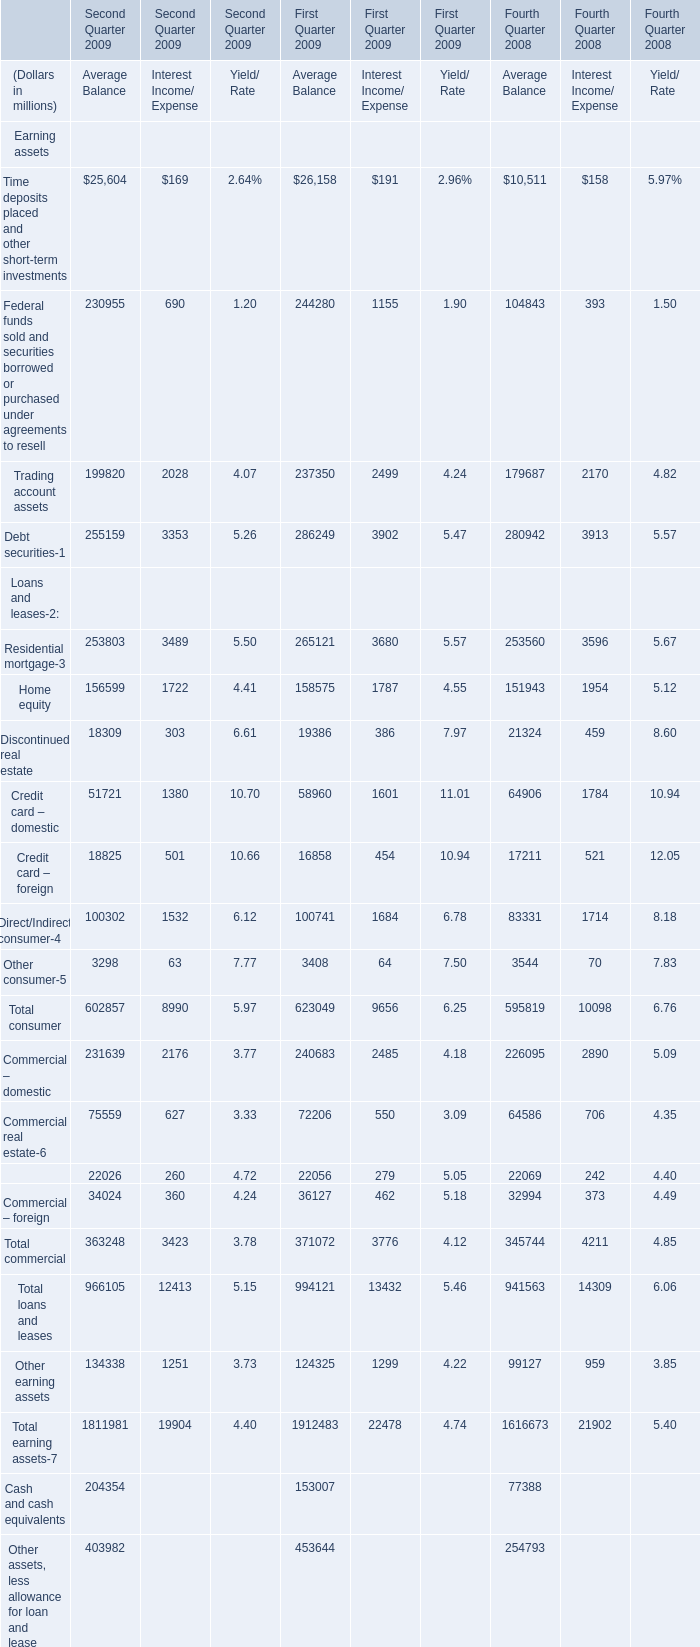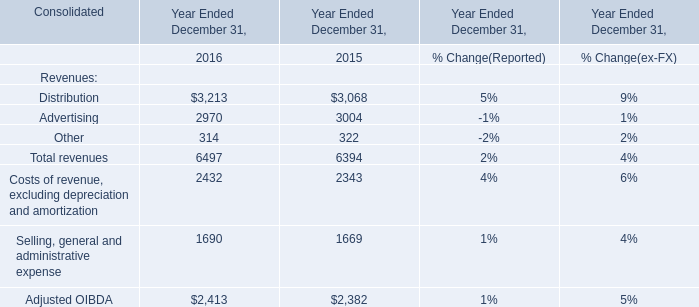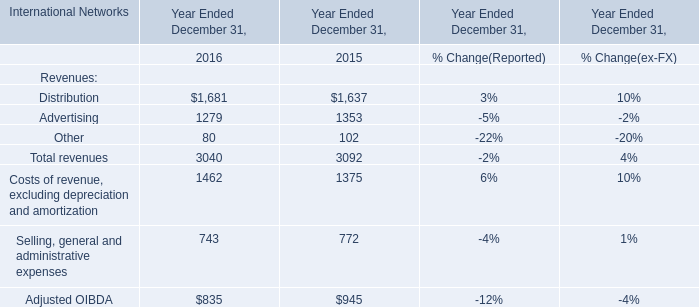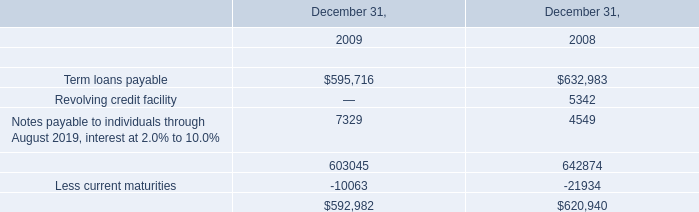what's the total amount of Less current maturities of December 31, 2008, and Commercial – domestic of First Quarter 2009 Interest Income/ Expense ? 
Computations: (21934.0 + 2485.0)
Answer: 24419.0. 